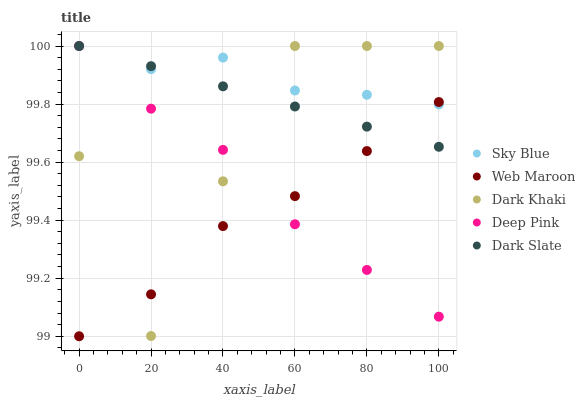Does Web Maroon have the minimum area under the curve?
Answer yes or no. Yes. Does Sky Blue have the maximum area under the curve?
Answer yes or no. Yes. Does Deep Pink have the minimum area under the curve?
Answer yes or no. No. Does Deep Pink have the maximum area under the curve?
Answer yes or no. No. Is Dark Slate the smoothest?
Answer yes or no. Yes. Is Dark Khaki the roughest?
Answer yes or no. Yes. Is Sky Blue the smoothest?
Answer yes or no. No. Is Sky Blue the roughest?
Answer yes or no. No. Does Web Maroon have the lowest value?
Answer yes or no. Yes. Does Deep Pink have the lowest value?
Answer yes or no. No. Does Dark Slate have the highest value?
Answer yes or no. Yes. Does Web Maroon have the highest value?
Answer yes or no. No. Does Deep Pink intersect Dark Khaki?
Answer yes or no. Yes. Is Deep Pink less than Dark Khaki?
Answer yes or no. No. Is Deep Pink greater than Dark Khaki?
Answer yes or no. No. 